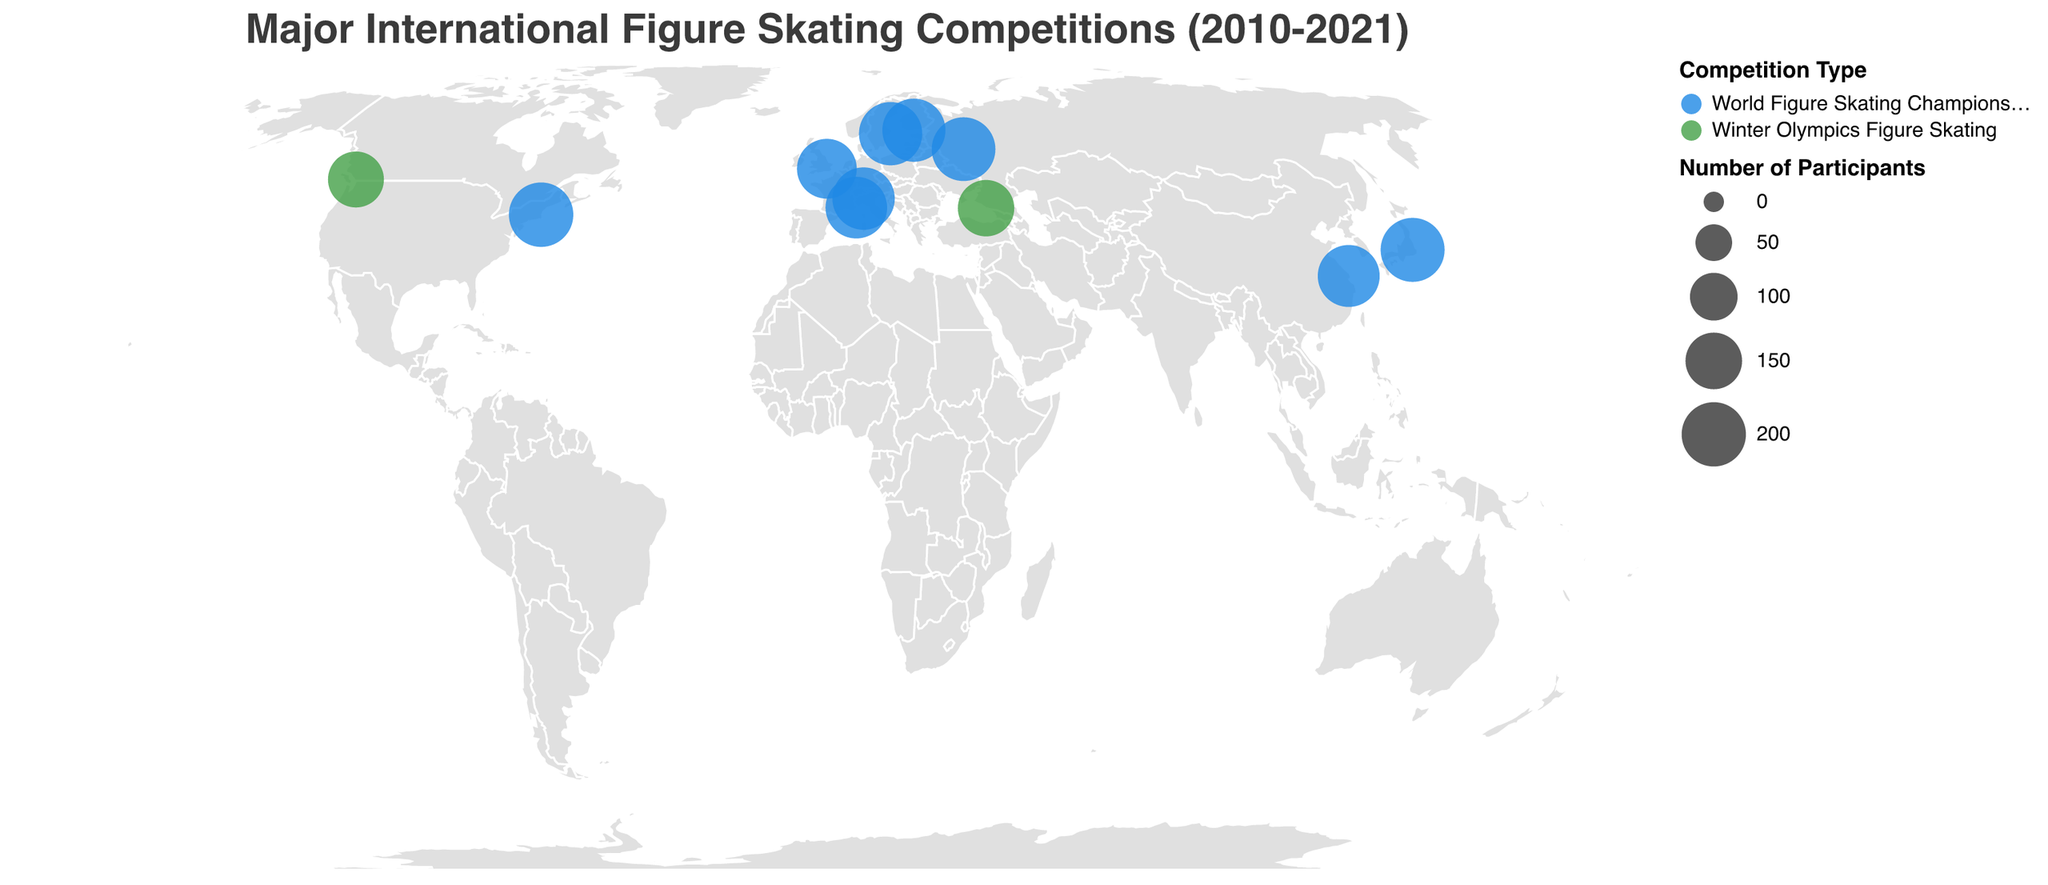What is the title of the figure? The title of the figure is displayed at the top and gives an overview of what the figure represents.
Answer: Major International Figure Skating Competitions (2010-2021) How many competitions were held in Europe? By counting the number of cities located in Europe on the map, we see Stockholm, Milan, Helsinki, Nice, London, and Moscow.
Answer: 6 Which city hosted the competition with the highest number of participants? By examining the size of the circles and the tooltip information, Boston had the highest number of participants with 201 in 2016.
Answer: Boston What are the colors used to distinguish between World Figure Skating Championships and Winter Olympics Figure Skating? The legend indicates the colors used for each competition type.
Answer: Blue for World Figure Skating Championships and Green for Winter Olympics Figure Skating Which event had fewer participants, the 2014 Winter Olympics in Sochi or the 2010 Winter Olympics in Vancouver? Comparing the two green circles and the tooltip information for Sochi and Vancouver, Sochi had fewer participants (149) compared to Vancouver (146).
Answer: Vancouver What is the average number of participants in the World Figure Skating Championships from 2010 to 2021? Summing the participants for each year of the World Figure Skating Championships and dividing by the number of these events: (193+198+187+192+201+184+170+182+196)/9 = 189.22
Answer: 189.22 Which continent hosted the most number of competitions? By identifying and counting the locations on the map, Europe hosted the most competitions, having 6 out of a total of 11.
Answer: Europe How does the number of participants in the 2019 World Figure Skating Championships in Saitama compare to that in the 2018 World Figure Skating Championships in Milan? By examining the size of the circles and the tooltip information, Saitama (198) had more participants than Milan (187).
Answer: More Which location hosted the competition in 2017, and how many participants were there? By referring to the tooltip information for the year 2017, Helsinki hosted the 2017 World Figure Skating Championships with 192 participants.
Answer: Helsinki, 192 How many times did a Winter Olympics Figure Skating competition occur in the given data? By counting the green circles corresponding to Winter Olympics Figure Skating on the map, there were 2 events: Vancouver 2010 and Sochi 2014.
Answer: 2 